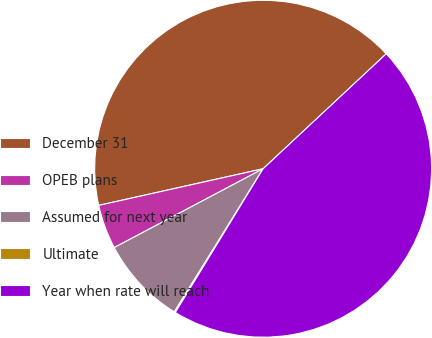<chart> <loc_0><loc_0><loc_500><loc_500><pie_chart><fcel>December 31<fcel>OPEB plans<fcel>Assumed for next year<fcel>Ultimate<fcel>Year when rate will reach<nl><fcel>41.53%<fcel>4.26%<fcel>8.41%<fcel>0.11%<fcel>45.68%<nl></chart> 